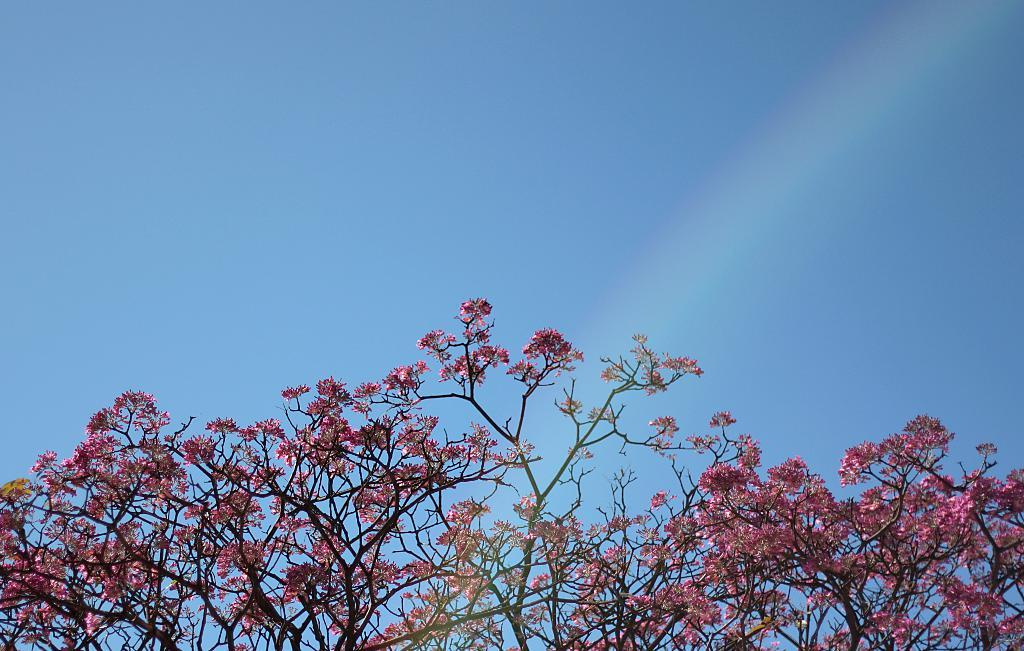What is the main subject of the picture? The main subject of the picture is a tree. What is special about the tree in the picture? The tree has pink flowers. What can be seen in the sky in the picture? The sky is visible at the top of the picture, and there is a rainbow in the sky. How many chin hairs can be seen on the tree in the picture? There are no chin hairs present on the tree in the picture, as it is a tree with pink flowers. Can you tell me how many times the committee jumped over the rainbow in the picture? There is no committee or jumping activity depicted in the picture; it features a tree with pink flowers and a rainbow in the sky. 